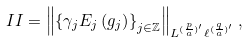<formula> <loc_0><loc_0><loc_500><loc_500>I I = \left \| \left \{ \gamma _ { j } E _ { j } \left ( g _ { j } \right ) \right \} _ { j \in \mathbb { Z } } \right \| _ { L ^ { ( \frac { p } { a } ) ^ { \prime } } \ell ^ { ( \frac { q } { a } ) ^ { \prime } } } ,</formula> 